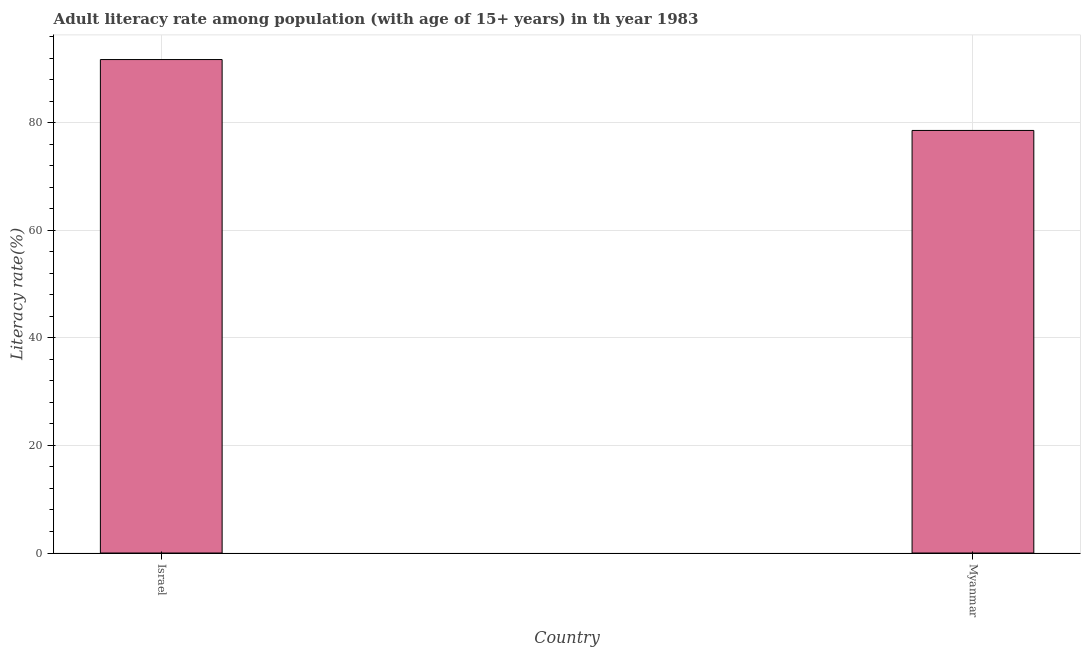Does the graph contain any zero values?
Your answer should be compact. No. Does the graph contain grids?
Provide a short and direct response. Yes. What is the title of the graph?
Your answer should be very brief. Adult literacy rate among population (with age of 15+ years) in th year 1983. What is the label or title of the Y-axis?
Your answer should be compact. Literacy rate(%). What is the adult literacy rate in Israel?
Provide a succinct answer. 91.75. Across all countries, what is the maximum adult literacy rate?
Your response must be concise. 91.75. Across all countries, what is the minimum adult literacy rate?
Ensure brevity in your answer.  78.57. In which country was the adult literacy rate minimum?
Your answer should be very brief. Myanmar. What is the sum of the adult literacy rate?
Make the answer very short. 170.32. What is the difference between the adult literacy rate in Israel and Myanmar?
Your answer should be very brief. 13.18. What is the average adult literacy rate per country?
Provide a succinct answer. 85.16. What is the median adult literacy rate?
Keep it short and to the point. 85.16. What is the ratio of the adult literacy rate in Israel to that in Myanmar?
Your answer should be very brief. 1.17. Is the adult literacy rate in Israel less than that in Myanmar?
Your answer should be compact. No. In how many countries, is the adult literacy rate greater than the average adult literacy rate taken over all countries?
Offer a very short reply. 1. Are all the bars in the graph horizontal?
Your response must be concise. No. How many countries are there in the graph?
Make the answer very short. 2. What is the difference between two consecutive major ticks on the Y-axis?
Ensure brevity in your answer.  20. What is the Literacy rate(%) of Israel?
Ensure brevity in your answer.  91.75. What is the Literacy rate(%) of Myanmar?
Make the answer very short. 78.57. What is the difference between the Literacy rate(%) in Israel and Myanmar?
Your answer should be compact. 13.18. What is the ratio of the Literacy rate(%) in Israel to that in Myanmar?
Provide a succinct answer. 1.17. 